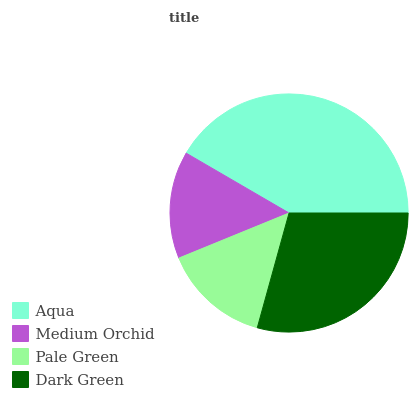Is Pale Green the minimum?
Answer yes or no. Yes. Is Aqua the maximum?
Answer yes or no. Yes. Is Medium Orchid the minimum?
Answer yes or no. No. Is Medium Orchid the maximum?
Answer yes or no. No. Is Aqua greater than Medium Orchid?
Answer yes or no. Yes. Is Medium Orchid less than Aqua?
Answer yes or no. Yes. Is Medium Orchid greater than Aqua?
Answer yes or no. No. Is Aqua less than Medium Orchid?
Answer yes or no. No. Is Dark Green the high median?
Answer yes or no. Yes. Is Medium Orchid the low median?
Answer yes or no. Yes. Is Medium Orchid the high median?
Answer yes or no. No. Is Aqua the low median?
Answer yes or no. No. 